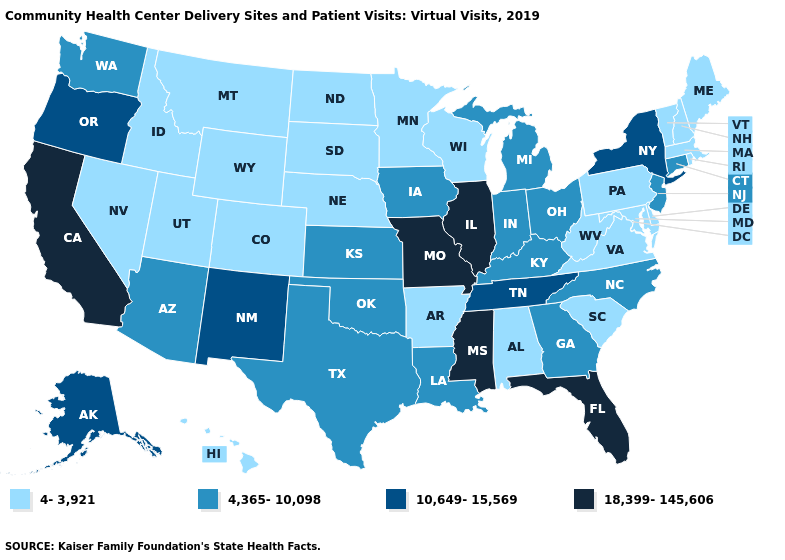Does the first symbol in the legend represent the smallest category?
Write a very short answer. Yes. What is the lowest value in states that border Indiana?
Give a very brief answer. 4,365-10,098. Does California have a higher value than Kentucky?
Write a very short answer. Yes. Among the states that border Illinois , which have the lowest value?
Keep it brief. Wisconsin. How many symbols are there in the legend?
Give a very brief answer. 4. What is the value of West Virginia?
Short answer required. 4-3,921. What is the value of Vermont?
Quick response, please. 4-3,921. What is the value of Alabama?
Quick response, please. 4-3,921. What is the value of Vermont?
Give a very brief answer. 4-3,921. Name the states that have a value in the range 4-3,921?
Be succinct. Alabama, Arkansas, Colorado, Delaware, Hawaii, Idaho, Maine, Maryland, Massachusetts, Minnesota, Montana, Nebraska, Nevada, New Hampshire, North Dakota, Pennsylvania, Rhode Island, South Carolina, South Dakota, Utah, Vermont, Virginia, West Virginia, Wisconsin, Wyoming. Name the states that have a value in the range 10,649-15,569?
Write a very short answer. Alaska, New Mexico, New York, Oregon, Tennessee. Name the states that have a value in the range 4,365-10,098?
Concise answer only. Arizona, Connecticut, Georgia, Indiana, Iowa, Kansas, Kentucky, Louisiana, Michigan, New Jersey, North Carolina, Ohio, Oklahoma, Texas, Washington. What is the lowest value in the USA?
Be succinct. 4-3,921. What is the lowest value in states that border Louisiana?
Be succinct. 4-3,921. What is the highest value in the USA?
Be succinct. 18,399-145,606. 